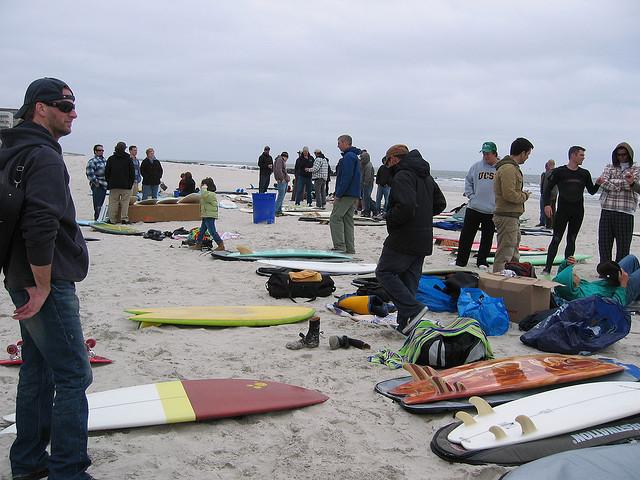Is it a sunny day?
Quick response, please. No. How many people are wearing hats?
Answer briefly. 3. How many fins does the white board have?
Answer briefly. 4. What type of hat does the man have on?
Keep it brief. Baseball cap. What are these people doing?
Keep it brief. Preparing to surf. 